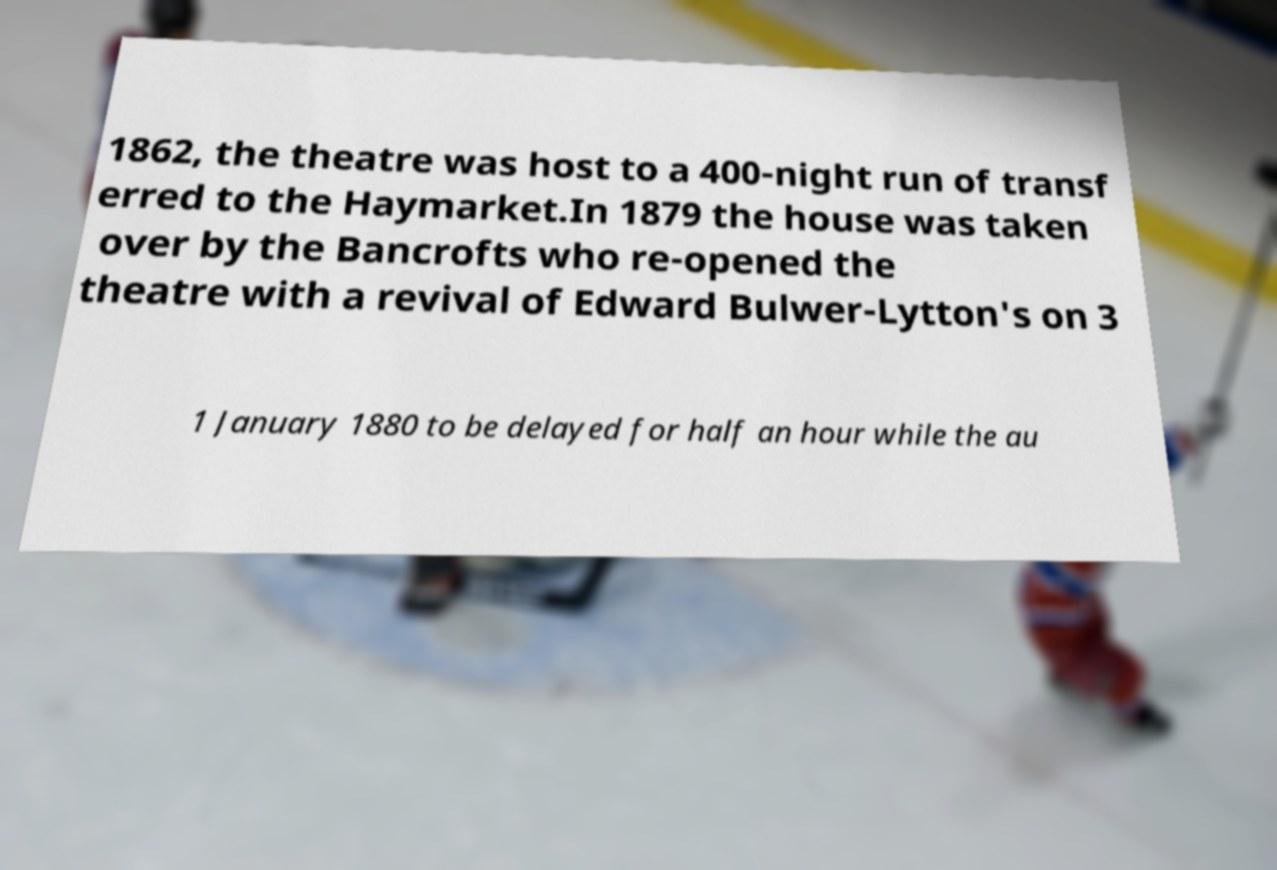There's text embedded in this image that I need extracted. Can you transcribe it verbatim? 1862, the theatre was host to a 400-night run of transf erred to the Haymarket.In 1879 the house was taken over by the Bancrofts who re-opened the theatre with a revival of Edward Bulwer-Lytton's on 3 1 January 1880 to be delayed for half an hour while the au 